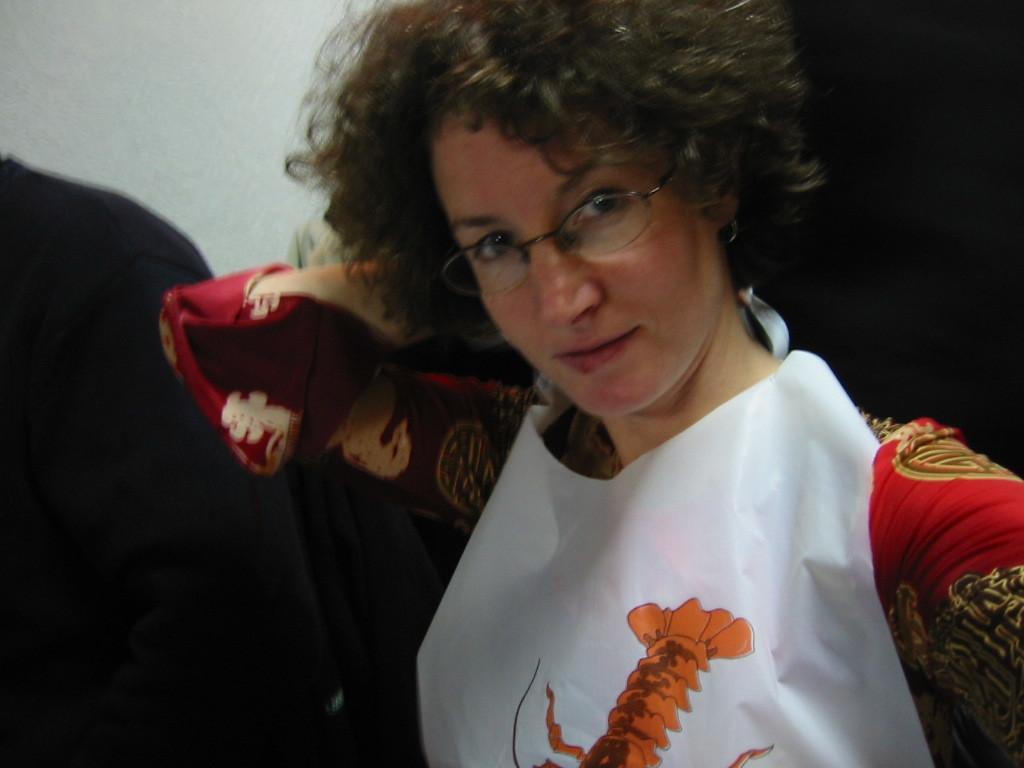Describe this image in one or two sentences. This picture seems to be of inside. On the right there is a woman wearing red color dress and white color apron seems to be standing. In the background we can see the wall. 